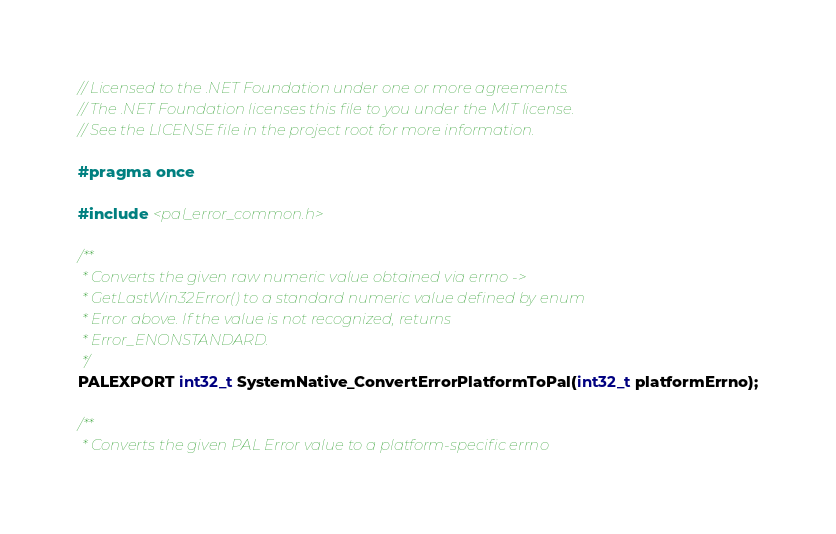<code> <loc_0><loc_0><loc_500><loc_500><_C_>// Licensed to the .NET Foundation under one or more agreements.
// The .NET Foundation licenses this file to you under the MIT license.
// See the LICENSE file in the project root for more information.

#pragma once

#include <pal_error_common.h>

/**
 * Converts the given raw numeric value obtained via errno ->
 * GetLastWin32Error() to a standard numeric value defined by enum
 * Error above. If the value is not recognized, returns
 * Error_ENONSTANDARD.
 */
PALEXPORT int32_t SystemNative_ConvertErrorPlatformToPal(int32_t platformErrno);

/**
 * Converts the given PAL Error value to a platform-specific errno</code> 